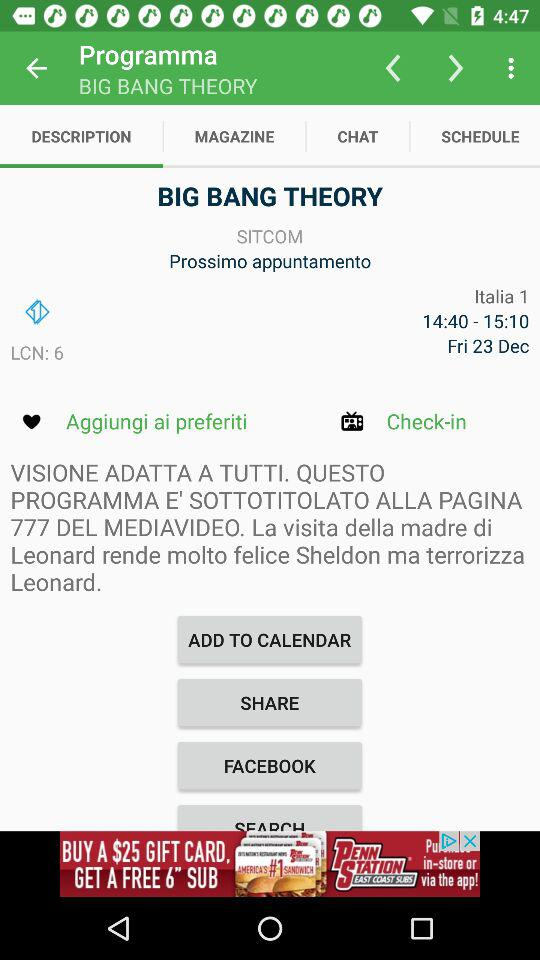What is the day shown on the mentioned date? The day is Friday. 